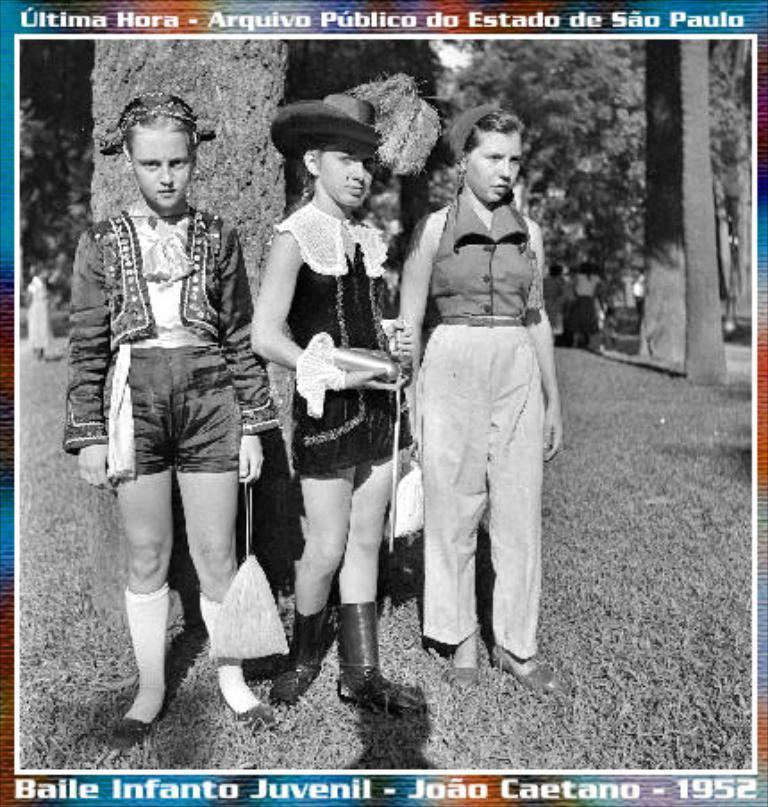In one or two sentences, can you explain what this image depicts? In this image I can see the black and white picture. In the picture I can see three people standing and wearing the dresses. I can see one person with the hat. In the background I can see few more people, trees and the sky. 